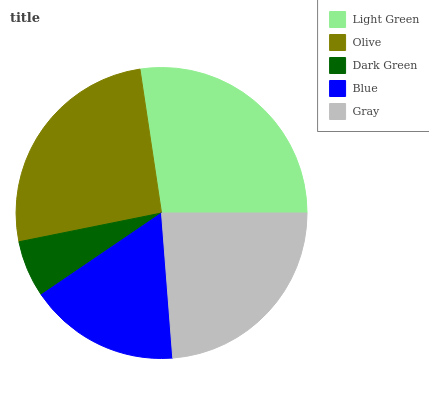Is Dark Green the minimum?
Answer yes or no. Yes. Is Light Green the maximum?
Answer yes or no. Yes. Is Olive the minimum?
Answer yes or no. No. Is Olive the maximum?
Answer yes or no. No. Is Light Green greater than Olive?
Answer yes or no. Yes. Is Olive less than Light Green?
Answer yes or no. Yes. Is Olive greater than Light Green?
Answer yes or no. No. Is Light Green less than Olive?
Answer yes or no. No. Is Gray the high median?
Answer yes or no. Yes. Is Gray the low median?
Answer yes or no. Yes. Is Olive the high median?
Answer yes or no. No. Is Blue the low median?
Answer yes or no. No. 